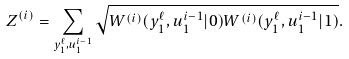<formula> <loc_0><loc_0><loc_500><loc_500>Z ^ { ( i ) } = \sum _ { y _ { 1 } ^ { \ell } , u _ { 1 } ^ { i - 1 } } \sqrt { W ^ { ( i ) } ( y _ { 1 } ^ { \ell } , u _ { 1 } ^ { i - 1 } | 0 ) W ^ { ( i ) } ( y _ { 1 } ^ { \ell } , u _ { 1 } ^ { i - 1 } | 1 ) } .</formula> 